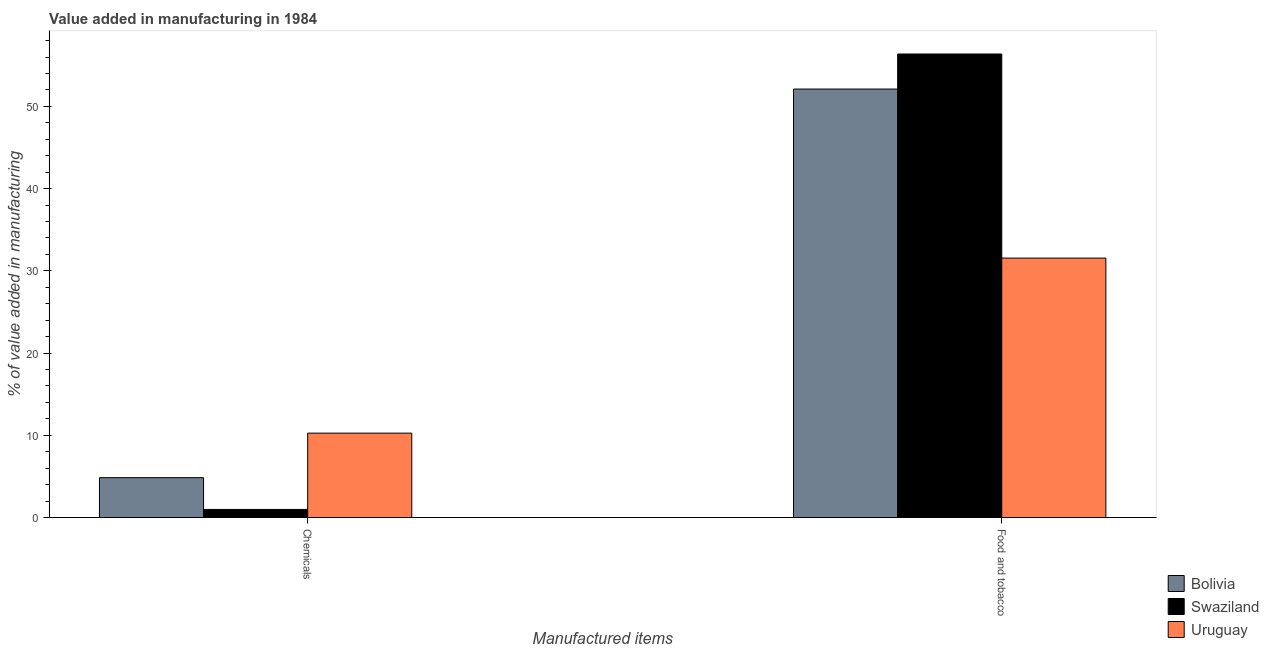How many groups of bars are there?
Your answer should be compact. 2. Are the number of bars per tick equal to the number of legend labels?
Make the answer very short. Yes. Are the number of bars on each tick of the X-axis equal?
Ensure brevity in your answer.  Yes. How many bars are there on the 2nd tick from the left?
Offer a terse response. 3. What is the label of the 1st group of bars from the left?
Ensure brevity in your answer.  Chemicals. What is the value added by manufacturing food and tobacco in Bolivia?
Keep it short and to the point. 52.11. Across all countries, what is the maximum value added by manufacturing food and tobacco?
Offer a terse response. 56.37. Across all countries, what is the minimum value added by manufacturing food and tobacco?
Your answer should be very brief. 31.55. In which country was the value added by  manufacturing chemicals maximum?
Your response must be concise. Uruguay. In which country was the value added by manufacturing food and tobacco minimum?
Make the answer very short. Uruguay. What is the total value added by  manufacturing chemicals in the graph?
Offer a terse response. 16.11. What is the difference between the value added by  manufacturing chemicals in Uruguay and that in Bolivia?
Offer a terse response. 5.42. What is the difference between the value added by  manufacturing chemicals in Bolivia and the value added by manufacturing food and tobacco in Uruguay?
Your answer should be compact. -26.7. What is the average value added by manufacturing food and tobacco per country?
Ensure brevity in your answer.  46.68. What is the difference between the value added by  manufacturing chemicals and value added by manufacturing food and tobacco in Bolivia?
Give a very brief answer. -47.26. In how many countries, is the value added by manufacturing food and tobacco greater than 32 %?
Your response must be concise. 2. What is the ratio of the value added by manufacturing food and tobacco in Swaziland to that in Bolivia?
Your answer should be compact. 1.08. What does the 1st bar from the left in Food and tobacco represents?
Your answer should be very brief. Bolivia. What does the 1st bar from the right in Chemicals represents?
Your answer should be compact. Uruguay. How many bars are there?
Offer a terse response. 6. How many countries are there in the graph?
Give a very brief answer. 3. What is the difference between two consecutive major ticks on the Y-axis?
Offer a very short reply. 10. Are the values on the major ticks of Y-axis written in scientific E-notation?
Ensure brevity in your answer.  No. Does the graph contain any zero values?
Give a very brief answer. No. Where does the legend appear in the graph?
Your answer should be compact. Bottom right. What is the title of the graph?
Offer a terse response. Value added in manufacturing in 1984. Does "Comoros" appear as one of the legend labels in the graph?
Provide a succinct answer. No. What is the label or title of the X-axis?
Provide a short and direct response. Manufactured items. What is the label or title of the Y-axis?
Your answer should be very brief. % of value added in manufacturing. What is the % of value added in manufacturing of Bolivia in Chemicals?
Offer a terse response. 4.85. What is the % of value added in manufacturing in Swaziland in Chemicals?
Keep it short and to the point. 0.99. What is the % of value added in manufacturing of Uruguay in Chemicals?
Your response must be concise. 10.27. What is the % of value added in manufacturing in Bolivia in Food and tobacco?
Your answer should be very brief. 52.11. What is the % of value added in manufacturing of Swaziland in Food and tobacco?
Ensure brevity in your answer.  56.37. What is the % of value added in manufacturing in Uruguay in Food and tobacco?
Offer a terse response. 31.55. Across all Manufactured items, what is the maximum % of value added in manufacturing in Bolivia?
Your response must be concise. 52.11. Across all Manufactured items, what is the maximum % of value added in manufacturing of Swaziland?
Give a very brief answer. 56.37. Across all Manufactured items, what is the maximum % of value added in manufacturing of Uruguay?
Your response must be concise. 31.55. Across all Manufactured items, what is the minimum % of value added in manufacturing in Bolivia?
Offer a very short reply. 4.85. Across all Manufactured items, what is the minimum % of value added in manufacturing in Swaziland?
Keep it short and to the point. 0.99. Across all Manufactured items, what is the minimum % of value added in manufacturing in Uruguay?
Give a very brief answer. 10.27. What is the total % of value added in manufacturing of Bolivia in the graph?
Provide a succinct answer. 56.96. What is the total % of value added in manufacturing in Swaziland in the graph?
Provide a short and direct response. 57.36. What is the total % of value added in manufacturing in Uruguay in the graph?
Your answer should be very brief. 41.82. What is the difference between the % of value added in manufacturing of Bolivia in Chemicals and that in Food and tobacco?
Make the answer very short. -47.26. What is the difference between the % of value added in manufacturing of Swaziland in Chemicals and that in Food and tobacco?
Provide a short and direct response. -55.38. What is the difference between the % of value added in manufacturing in Uruguay in Chemicals and that in Food and tobacco?
Keep it short and to the point. -21.29. What is the difference between the % of value added in manufacturing of Bolivia in Chemicals and the % of value added in manufacturing of Swaziland in Food and tobacco?
Your answer should be very brief. -51.52. What is the difference between the % of value added in manufacturing of Bolivia in Chemicals and the % of value added in manufacturing of Uruguay in Food and tobacco?
Offer a terse response. -26.7. What is the difference between the % of value added in manufacturing in Swaziland in Chemicals and the % of value added in manufacturing in Uruguay in Food and tobacco?
Your answer should be compact. -30.57. What is the average % of value added in manufacturing in Bolivia per Manufactured items?
Make the answer very short. 28.48. What is the average % of value added in manufacturing of Swaziland per Manufactured items?
Make the answer very short. 28.68. What is the average % of value added in manufacturing in Uruguay per Manufactured items?
Make the answer very short. 20.91. What is the difference between the % of value added in manufacturing of Bolivia and % of value added in manufacturing of Swaziland in Chemicals?
Ensure brevity in your answer.  3.86. What is the difference between the % of value added in manufacturing in Bolivia and % of value added in manufacturing in Uruguay in Chemicals?
Give a very brief answer. -5.42. What is the difference between the % of value added in manufacturing of Swaziland and % of value added in manufacturing of Uruguay in Chemicals?
Offer a terse response. -9.28. What is the difference between the % of value added in manufacturing in Bolivia and % of value added in manufacturing in Swaziland in Food and tobacco?
Give a very brief answer. -4.26. What is the difference between the % of value added in manufacturing of Bolivia and % of value added in manufacturing of Uruguay in Food and tobacco?
Keep it short and to the point. 20.55. What is the difference between the % of value added in manufacturing of Swaziland and % of value added in manufacturing of Uruguay in Food and tobacco?
Ensure brevity in your answer.  24.82. What is the ratio of the % of value added in manufacturing in Bolivia in Chemicals to that in Food and tobacco?
Give a very brief answer. 0.09. What is the ratio of the % of value added in manufacturing in Swaziland in Chemicals to that in Food and tobacco?
Keep it short and to the point. 0.02. What is the ratio of the % of value added in manufacturing of Uruguay in Chemicals to that in Food and tobacco?
Provide a short and direct response. 0.33. What is the difference between the highest and the second highest % of value added in manufacturing in Bolivia?
Your answer should be very brief. 47.26. What is the difference between the highest and the second highest % of value added in manufacturing of Swaziland?
Your answer should be very brief. 55.38. What is the difference between the highest and the second highest % of value added in manufacturing of Uruguay?
Your answer should be very brief. 21.29. What is the difference between the highest and the lowest % of value added in manufacturing in Bolivia?
Give a very brief answer. 47.26. What is the difference between the highest and the lowest % of value added in manufacturing in Swaziland?
Your answer should be compact. 55.38. What is the difference between the highest and the lowest % of value added in manufacturing of Uruguay?
Your answer should be compact. 21.29. 